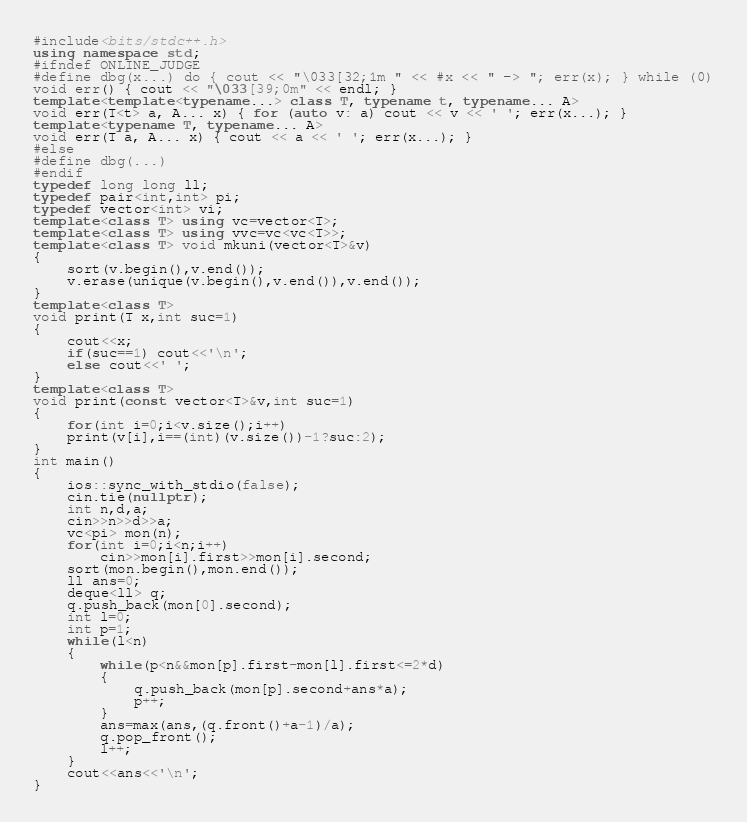<code> <loc_0><loc_0><loc_500><loc_500><_C++_>#include<bits/stdc++.h>
using namespace std;
#ifndef ONLINE_JUDGE
#define dbg(x...) do { cout << "\033[32;1m " << #x << " -> "; err(x); } while (0)
void err() { cout << "\033[39;0m" << endl; }
template<template<typename...> class T, typename t, typename... A>
void err(T<t> a, A... x) { for (auto v: a) cout << v << ' '; err(x...); }
template<typename T, typename... A>
void err(T a, A... x) { cout << a << ' '; err(x...); }
#else
#define dbg(...)
#endif
typedef long long ll;
typedef pair<int,int> pi;
typedef vector<int> vi;
template<class T> using vc=vector<T>;
template<class T> using vvc=vc<vc<T>>;
template<class T> void mkuni(vector<T>&v)
{
    sort(v.begin(),v.end());
    v.erase(unique(v.begin(),v.end()),v.end());
}
template<class T>
void print(T x,int suc=1)
{
    cout<<x;
    if(suc==1) cout<<'\n';
    else cout<<' ';
}
template<class T>
void print(const vector<T>&v,int suc=1)
{
    for(int i=0;i<v.size();i++)
    print(v[i],i==(int)(v.size())-1?suc:2);
}
int main()
{
    ios::sync_with_stdio(false);
    cin.tie(nullptr);
    int n,d,a;
    cin>>n>>d>>a;
    vc<pi> mon(n);
    for(int i=0;i<n;i++)
        cin>>mon[i].first>>mon[i].second;
    sort(mon.begin(),mon.end());
    ll ans=0;
    deque<ll> q;
    q.push_back(mon[0].second);
    int l=0;
    int p=1;
    while(l<n)
    {
        while(p<n&&mon[p].first-mon[l].first<=2*d)
        {
            q.push_back(mon[p].second+ans*a);
            p++;
        }
        ans=max(ans,(q.front()+a-1)/a);
        q.pop_front();
        l++;
    }
    cout<<ans<<'\n';
}</code> 